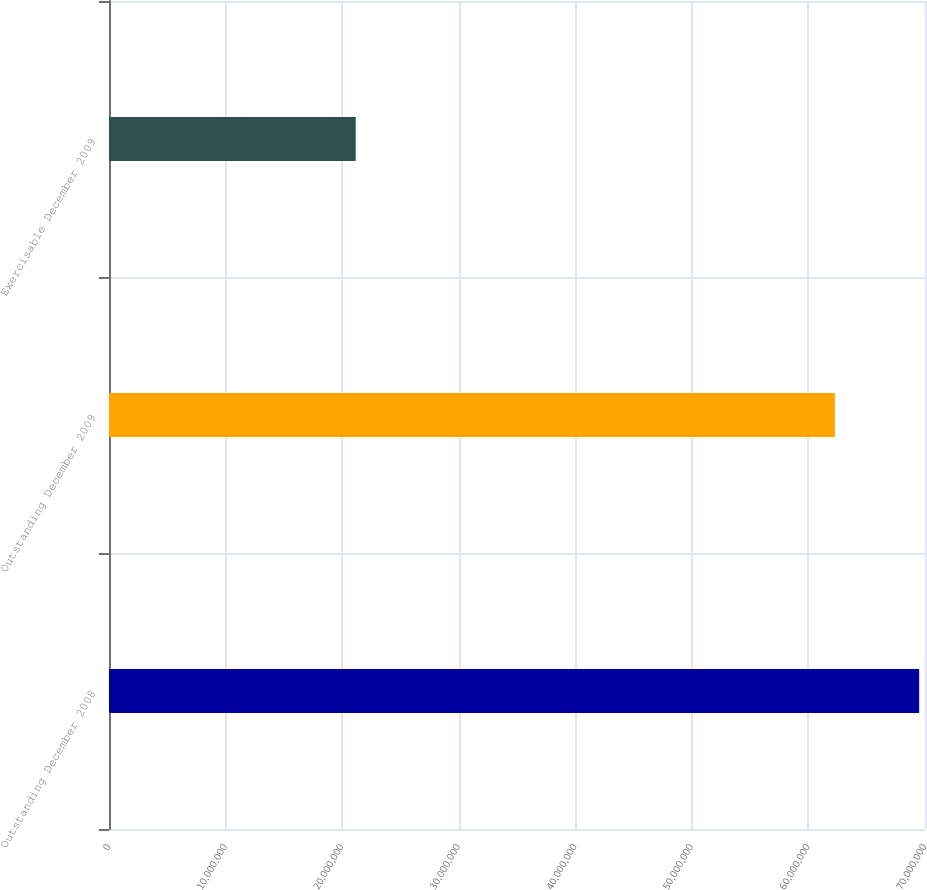<chart> <loc_0><loc_0><loc_500><loc_500><bar_chart><fcel>Outstanding December 2008<fcel>Outstanding December 2009<fcel>Exercisable December 2009<nl><fcel>6.95015e+07<fcel>6.22721e+07<fcel>2.11641e+07<nl></chart> 